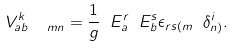<formula> <loc_0><loc_0><loc_500><loc_500>V _ { a b \ \ m n } ^ { k } = \frac { 1 } { g } \ E _ { a } ^ { r } \ E _ { b } ^ { s } \epsilon _ { r s ( m } \ \delta _ { n ) } ^ { i } .</formula> 